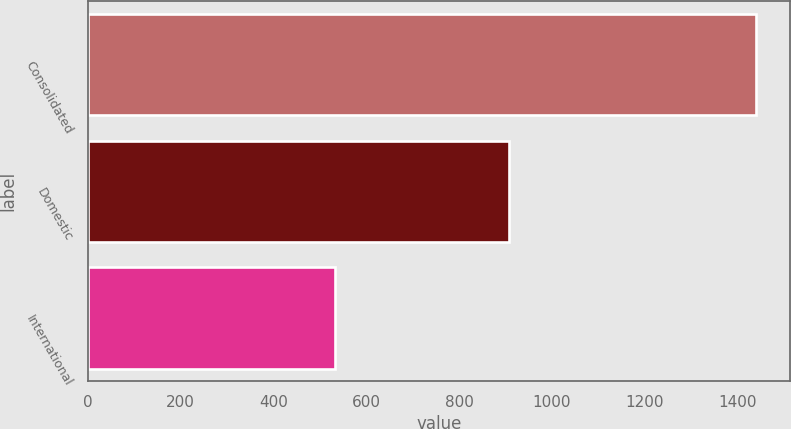<chart> <loc_0><loc_0><loc_500><loc_500><bar_chart><fcel>Consolidated<fcel>Domestic<fcel>International<nl><fcel>1439.8<fcel>908.2<fcel>531.6<nl></chart> 